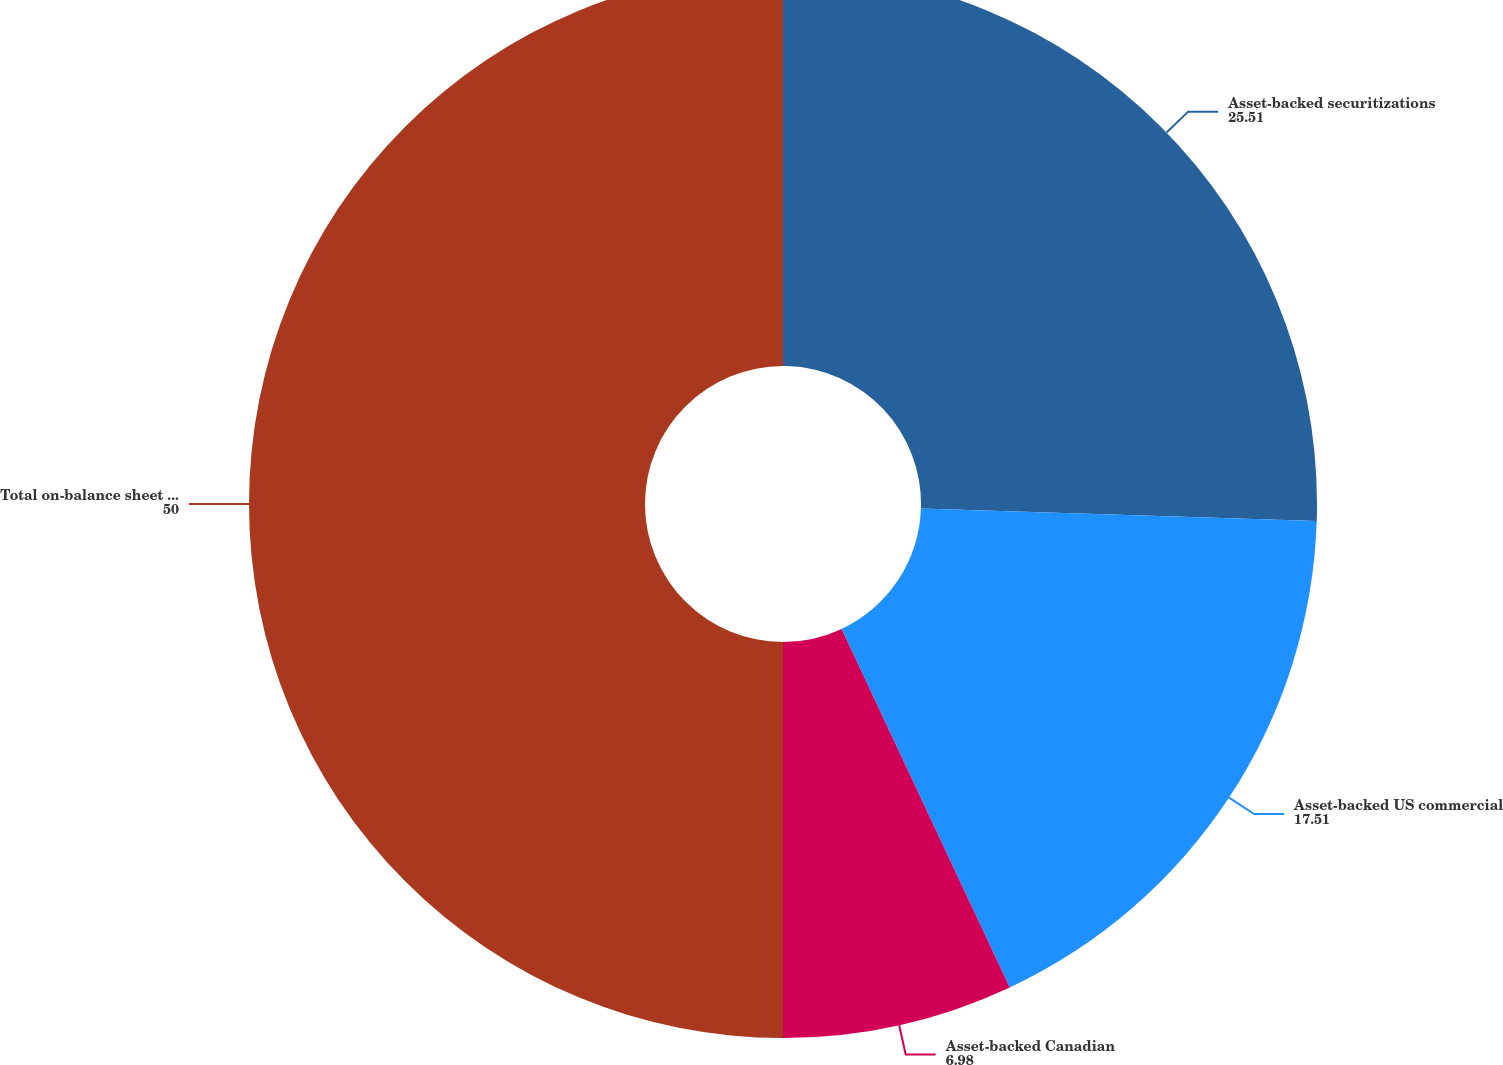Convert chart. <chart><loc_0><loc_0><loc_500><loc_500><pie_chart><fcel>Asset-backed securitizations<fcel>Asset-backed US commercial<fcel>Asset-backed Canadian<fcel>Total on-balance sheet assets<nl><fcel>25.51%<fcel>17.51%<fcel>6.98%<fcel>50.0%<nl></chart> 